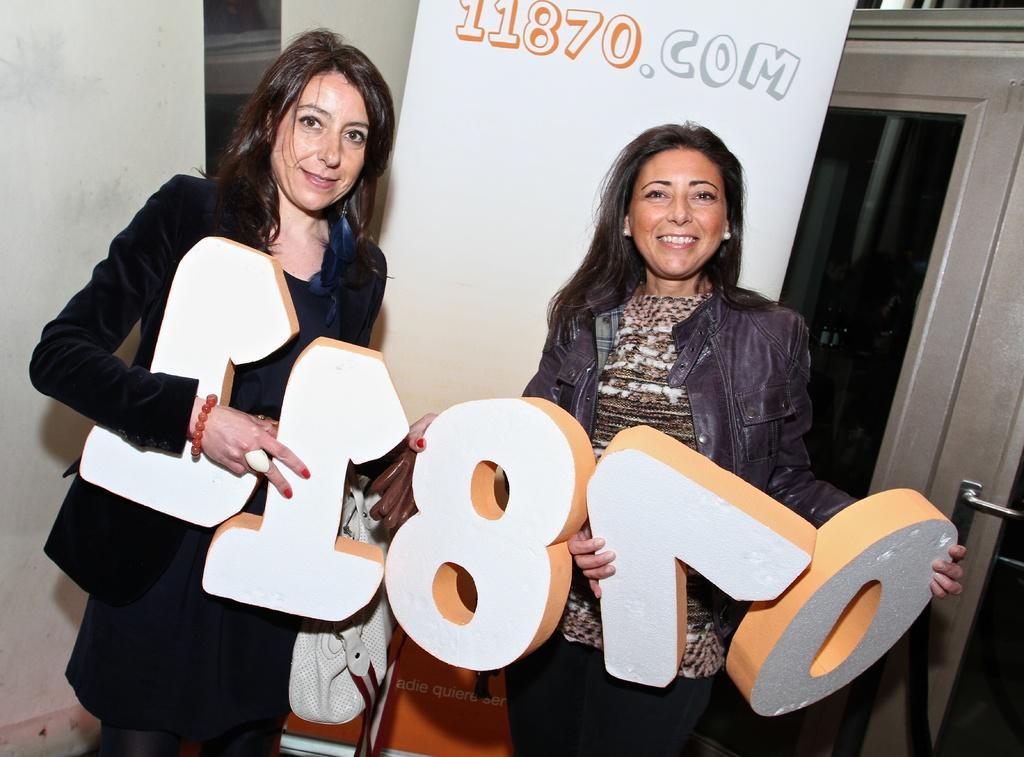How would you summarize this image in a sentence or two? In this image I can see a woman wearing black colored dress and another woman wearing brown colored dress are standing and and holding few white and brown colored objects in their hands. In the background I can see the door, a white colored banner and the white colored wall. 